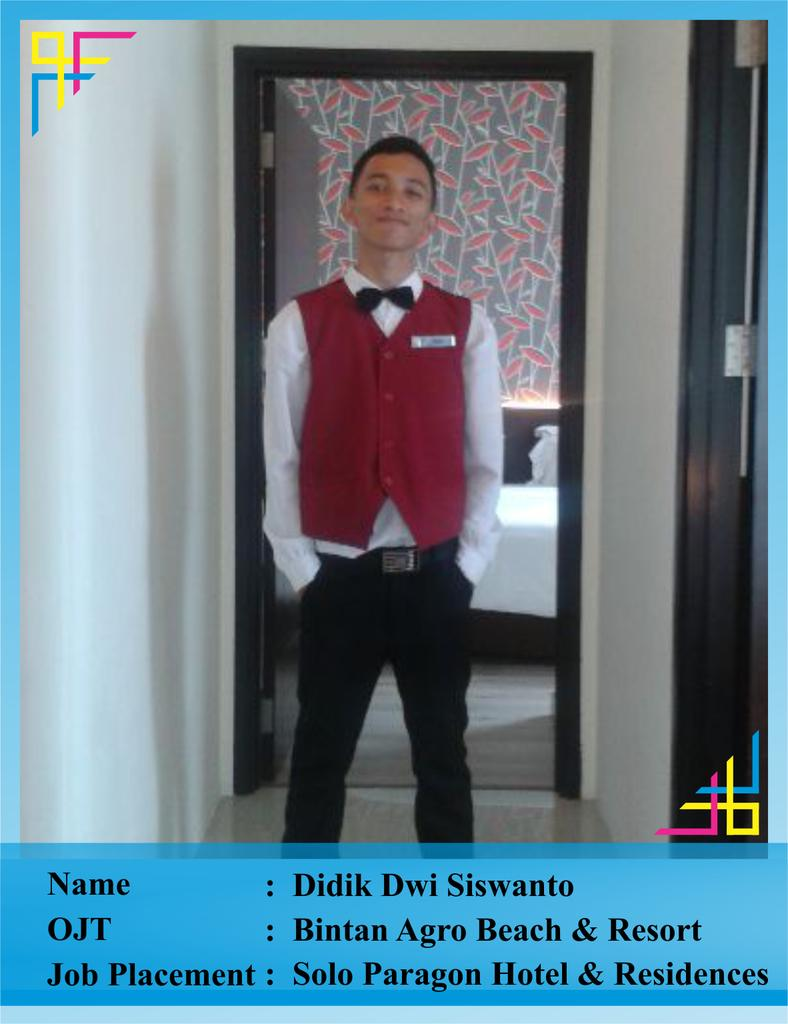What can be observed about the image's appearance? The image appears to be edited. Who or what can be seen in the image? There is a person standing in the image. What type of structures are present in the image? There are walls and a door in the image. Are there any other objects visible in the image? Yes, there are other objects in the image. Can you describe any text or writing on the image? There are words on the image. What type of education is the person in the image pursuing? There is no information about the person's education in the image. Is the person wearing a scarf in the image? The image does not provide information about the person's clothing, including whether they are wearing a scarf or not. 